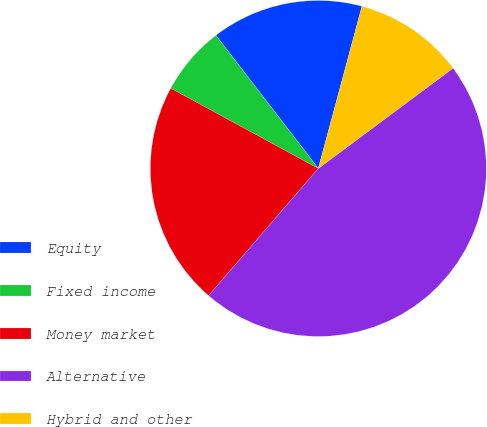Convert chart. <chart><loc_0><loc_0><loc_500><loc_500><pie_chart><fcel>Equity<fcel>Fixed income<fcel>Money market<fcel>Alternative<fcel>Hybrid and other<nl><fcel>14.62%<fcel>6.64%<fcel>21.59%<fcel>46.51%<fcel>10.63%<nl></chart> 